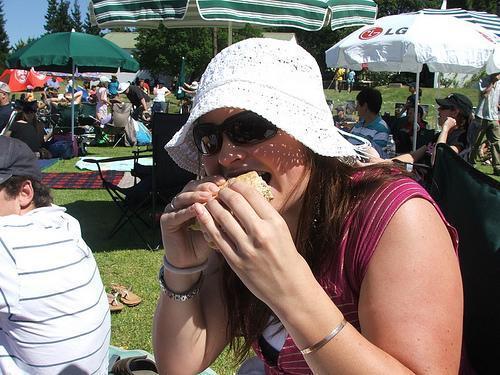How many chairs can be seen?
Give a very brief answer. 2. How many umbrellas are visible?
Give a very brief answer. 3. How many people are there?
Give a very brief answer. 4. 